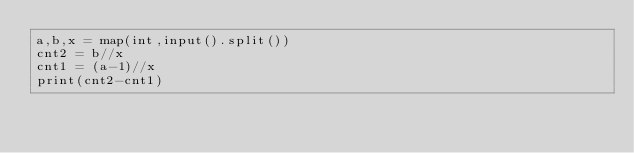<code> <loc_0><loc_0><loc_500><loc_500><_Python_>a,b,x = map(int,input().split())
cnt2 = b//x
cnt1 = (a-1)//x
print(cnt2-cnt1)</code> 